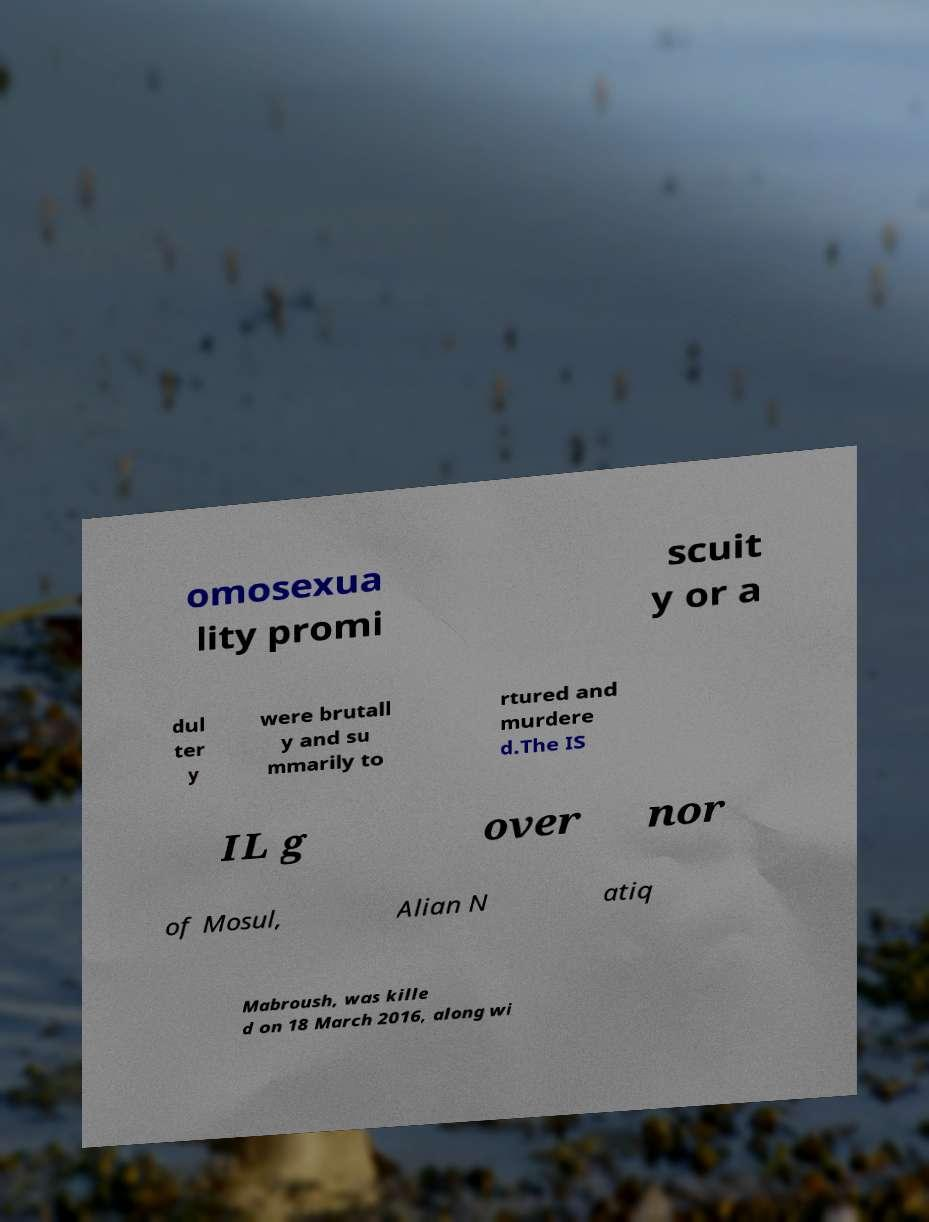Could you extract and type out the text from this image? omosexua lity promi scuit y or a dul ter y were brutall y and su mmarily to rtured and murdere d.The IS IL g over nor of Mosul, Alian N atiq Mabroush, was kille d on 18 March 2016, along wi 